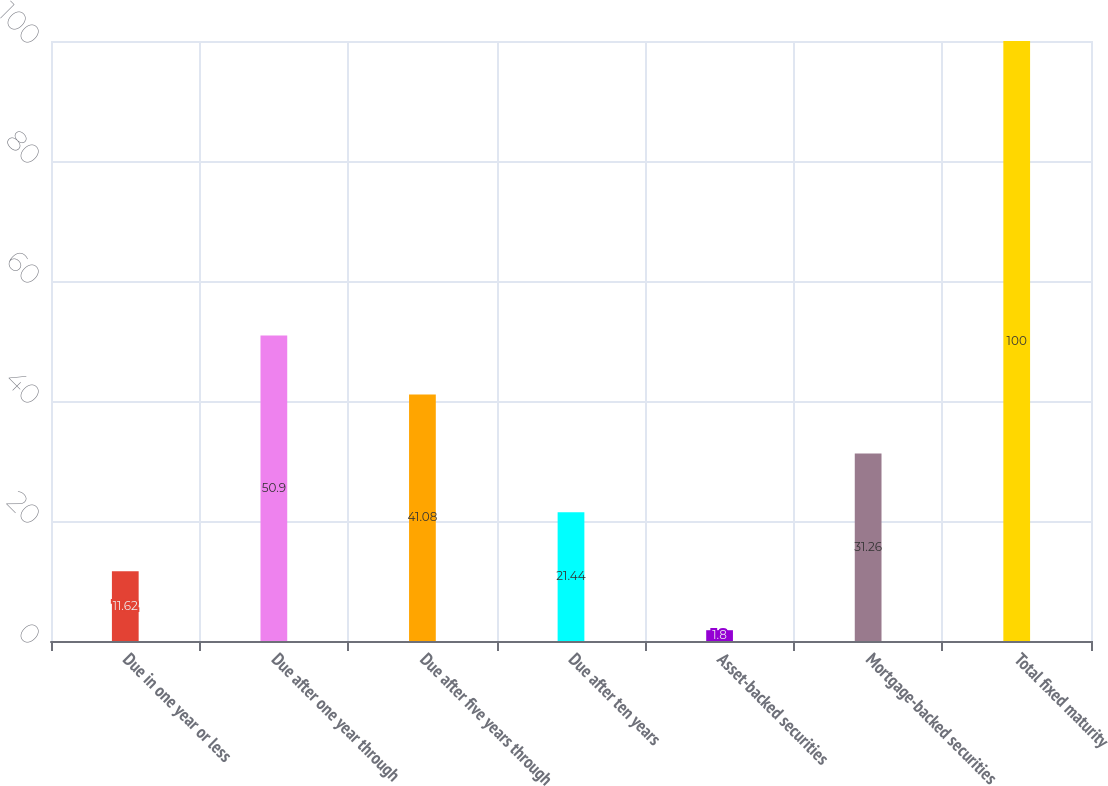<chart> <loc_0><loc_0><loc_500><loc_500><bar_chart><fcel>Due in one year or less<fcel>Due after one year through<fcel>Due after five years through<fcel>Due after ten years<fcel>Asset-backed securities<fcel>Mortgage-backed securities<fcel>Total fixed maturity<nl><fcel>11.62<fcel>50.9<fcel>41.08<fcel>21.44<fcel>1.8<fcel>31.26<fcel>100<nl></chart> 